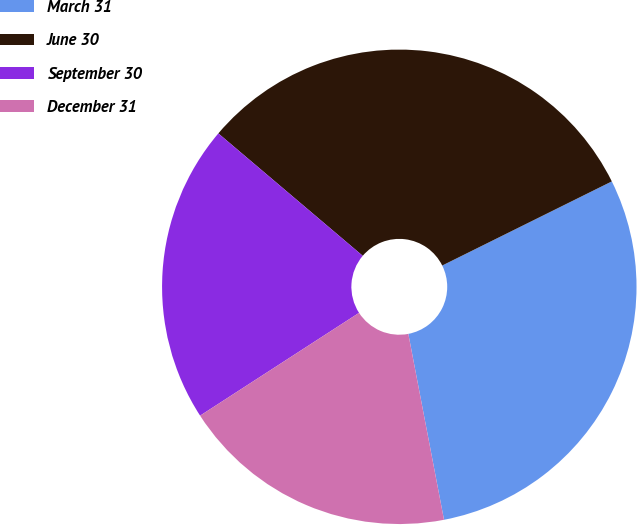Convert chart to OTSL. <chart><loc_0><loc_0><loc_500><loc_500><pie_chart><fcel>March 31<fcel>June 30<fcel>September 30<fcel>December 31<nl><fcel>29.31%<fcel>31.48%<fcel>20.33%<fcel>18.88%<nl></chart> 